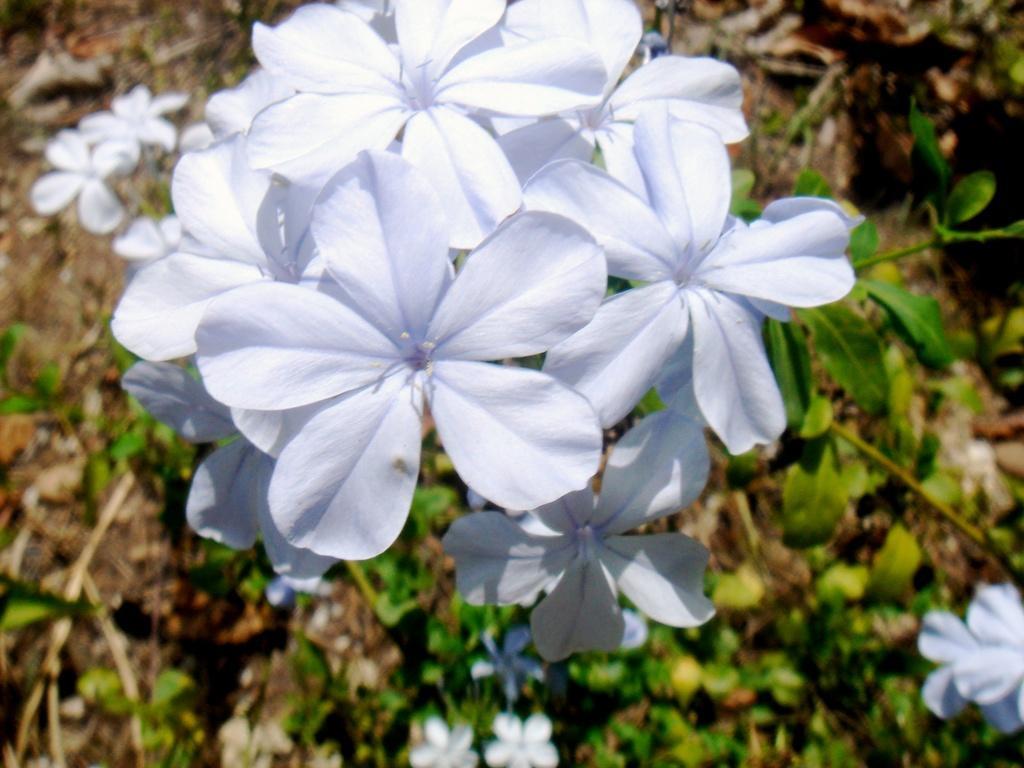Could you give a brief overview of what you see in this image? This image consists of plants. There are flowers in the middle. They are in white color. 